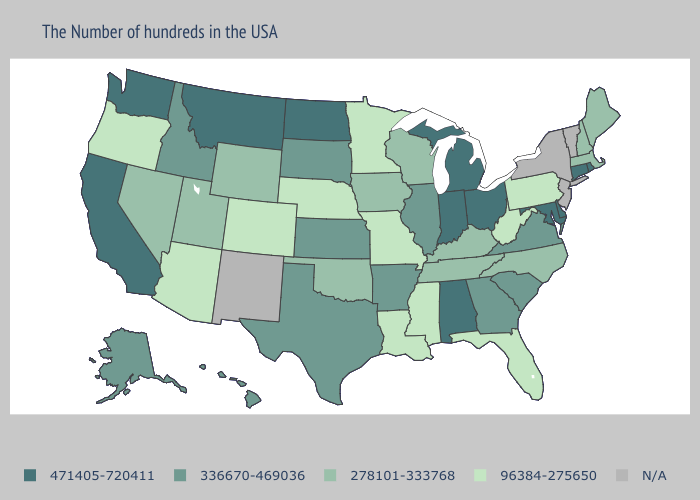Which states have the lowest value in the MidWest?
Write a very short answer. Missouri, Minnesota, Nebraska. Does Virginia have the lowest value in the South?
Be succinct. No. Does Florida have the lowest value in the USA?
Short answer required. Yes. What is the value of Virginia?
Answer briefly. 336670-469036. What is the value of North Carolina?
Answer briefly. 278101-333768. Name the states that have a value in the range 278101-333768?
Short answer required. Maine, Massachusetts, New Hampshire, North Carolina, Kentucky, Tennessee, Wisconsin, Iowa, Oklahoma, Wyoming, Utah, Nevada. Among the states that border Nebraska , which have the highest value?
Quick response, please. Kansas, South Dakota. What is the highest value in states that border Florida?
Short answer required. 471405-720411. Is the legend a continuous bar?
Be succinct. No. Which states have the lowest value in the Northeast?
Quick response, please. Pennsylvania. What is the highest value in the USA?
Answer briefly. 471405-720411. Is the legend a continuous bar?
Be succinct. No. How many symbols are there in the legend?
Short answer required. 5. What is the value of Colorado?
Write a very short answer. 96384-275650. 